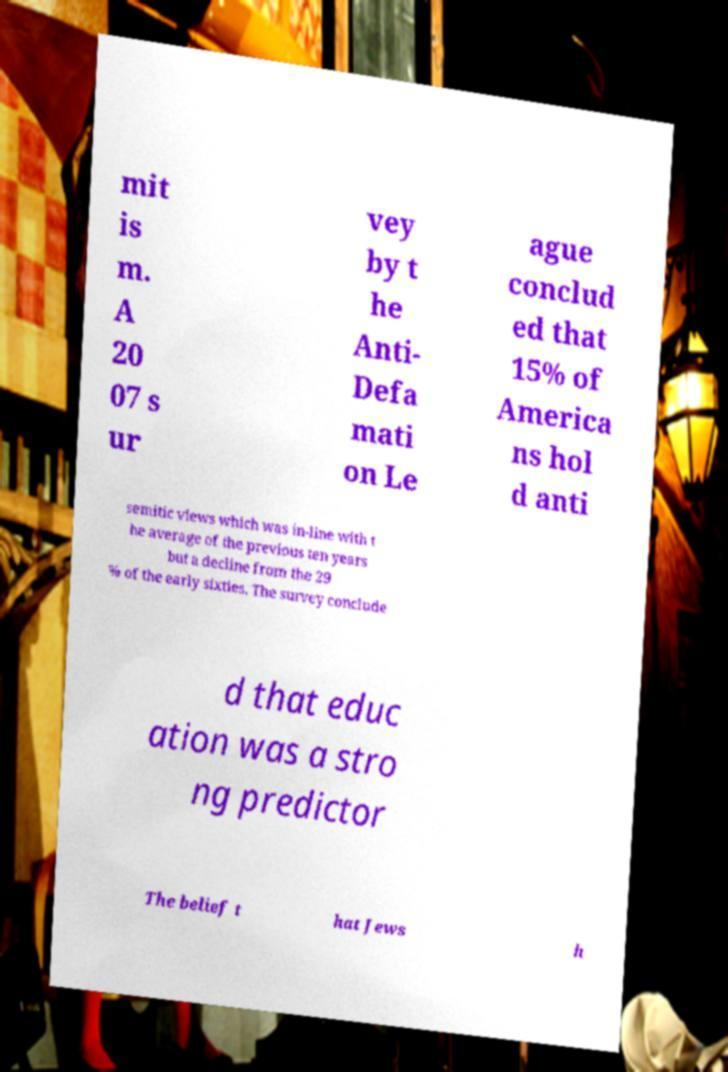Please read and relay the text visible in this image. What does it say? mit is m. A 20 07 s ur vey by t he Anti- Defa mati on Le ague conclud ed that 15% of America ns hol d anti semitic views which was in-line with t he average of the previous ten years but a decline from the 29 % of the early sixties. The survey conclude d that educ ation was a stro ng predictor The belief t hat Jews h 